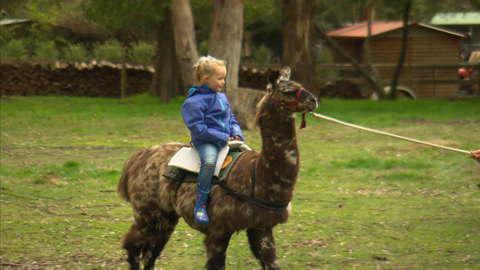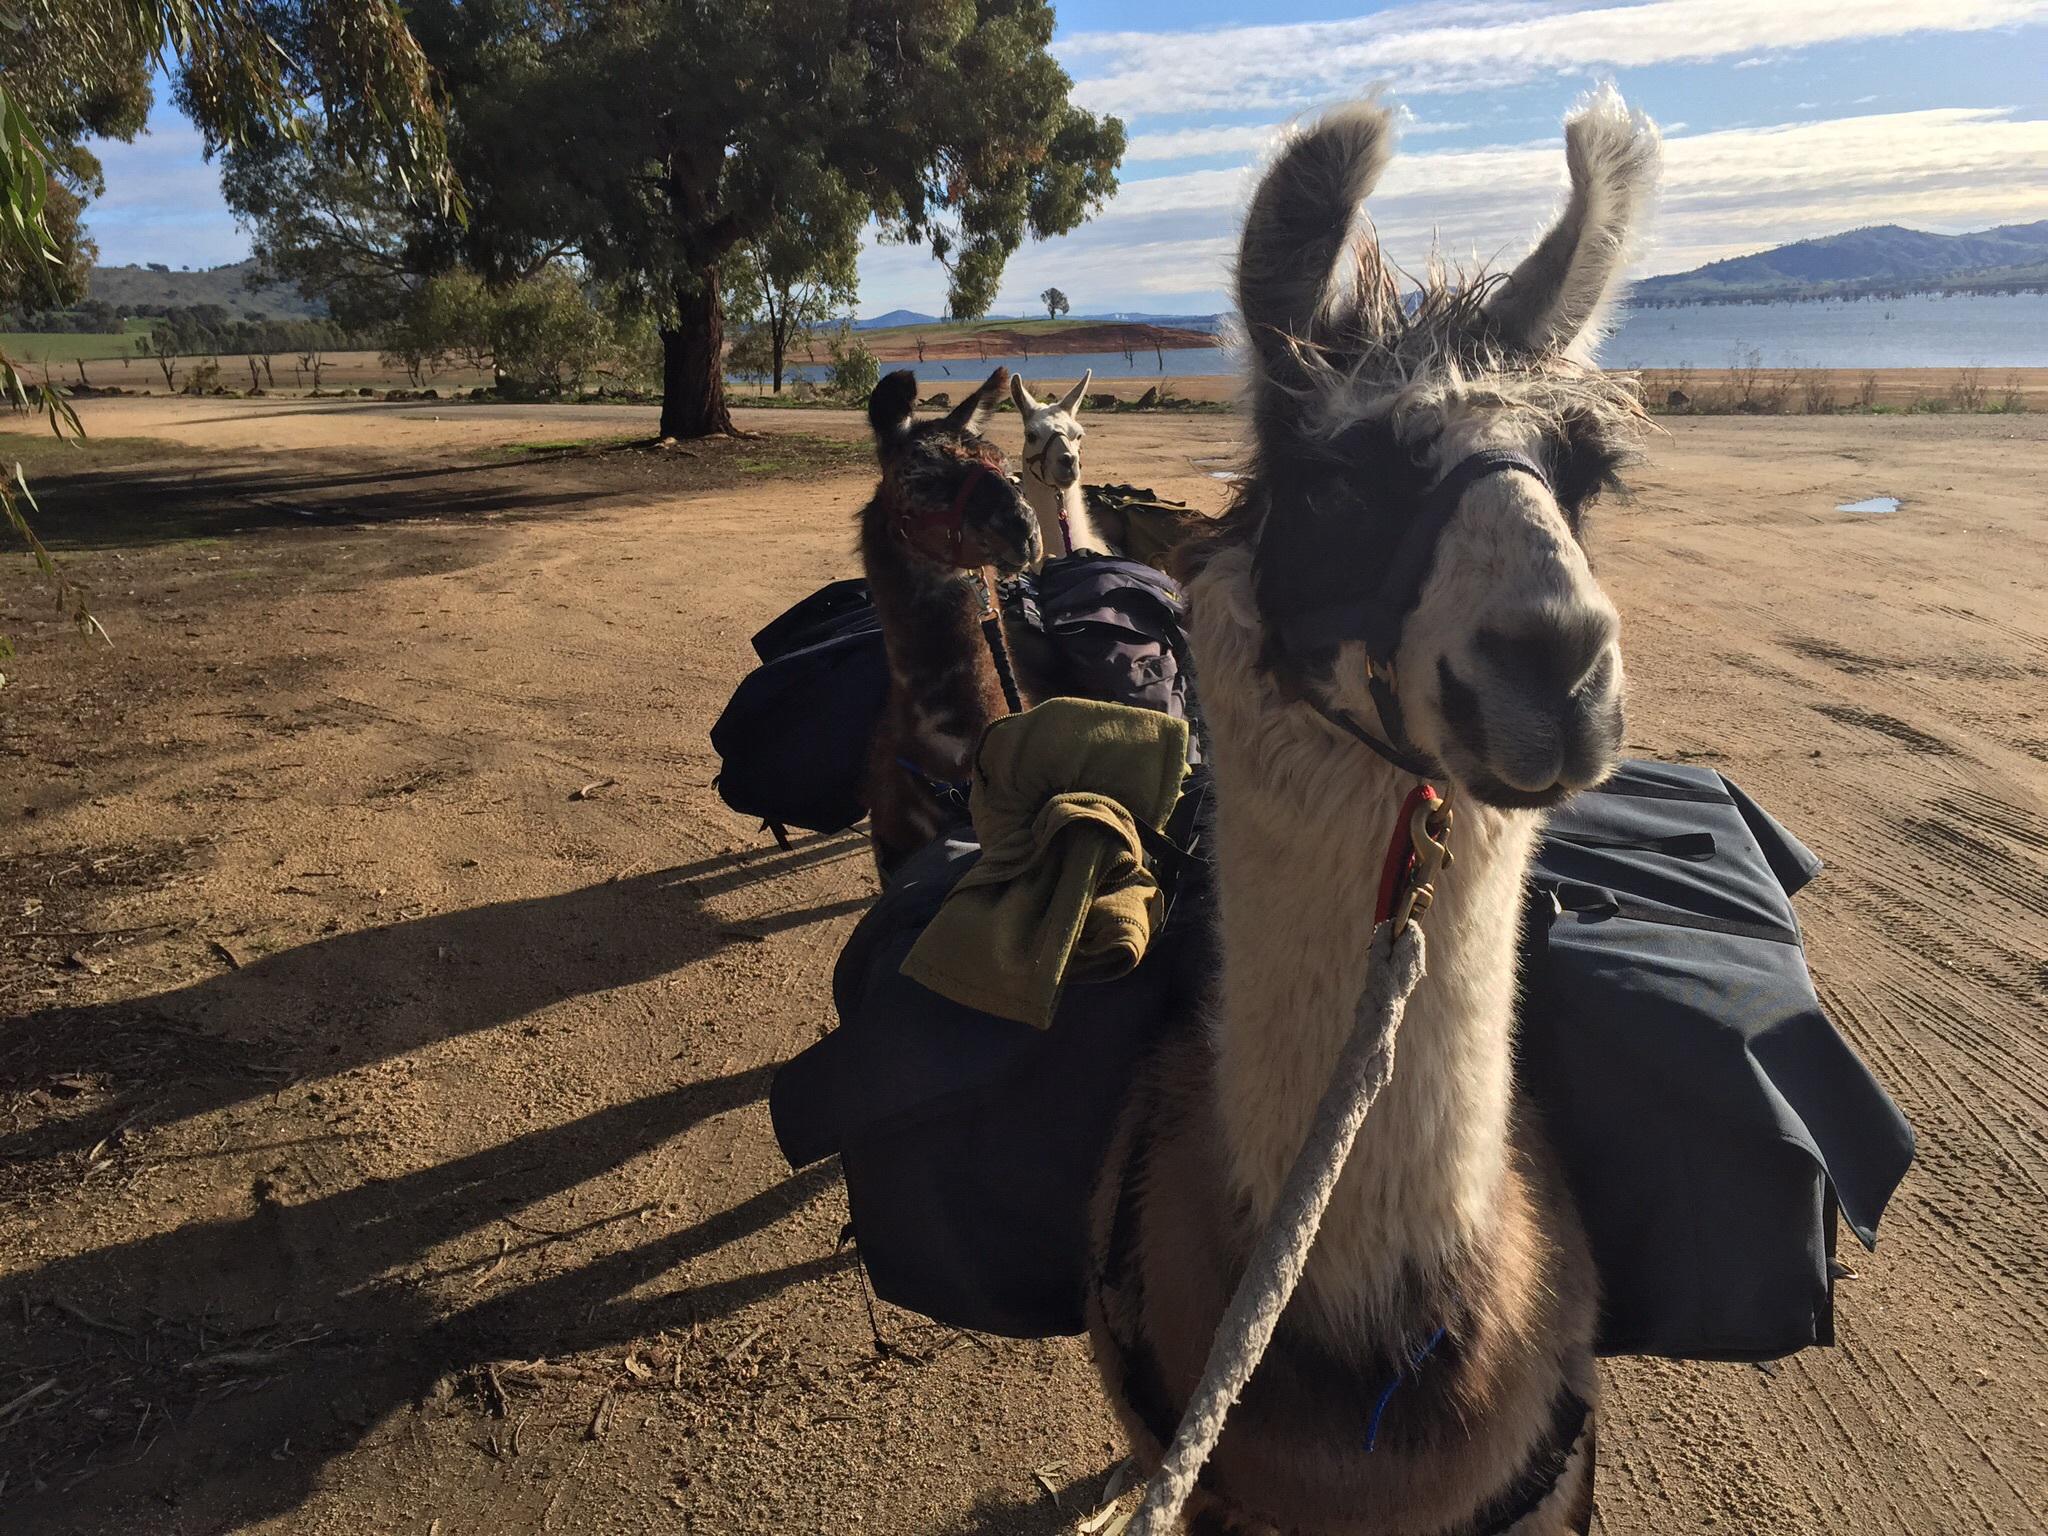The first image is the image on the left, the second image is the image on the right. Analyze the images presented: Is the assertion "A white rope is extending from the red harness on a right-facing llama with a mottled brown coat in one image." valid? Answer yes or no. Yes. The first image is the image on the left, the second image is the image on the right. Analyze the images presented: Is the assertion "There is at least one human in the pair of images." valid? Answer yes or no. Yes. 